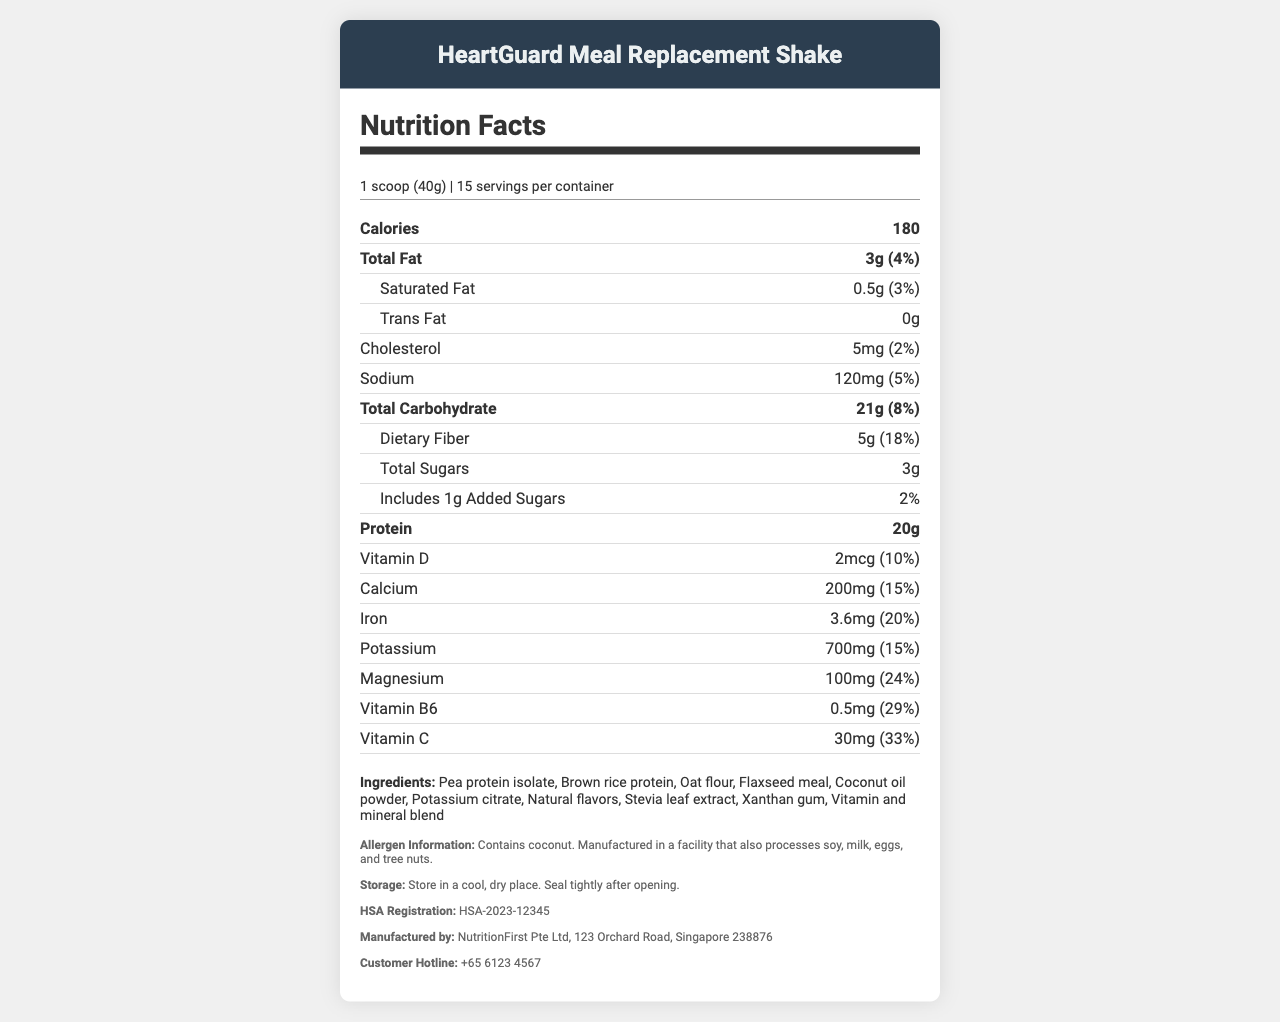what is the product name? The product name is clearly stated at the top of the document.
Answer: HeartGuard Meal Replacement Shake how many servings are there per container? The document lists "servings per container" as 15.
Answer: 15 servings how much potassium is there per serving? The document under the potassium section lists the amount as 700mg.
Answer: 700mg what is the daily value percentage of dietary fiber? The document specifies the daily value percentage of dietary fiber as 18%.
Answer: 18% what is the total carbohydrate content per serving? The total carbohydrate content per serving is listed as 21g.
Answer: 21g how many calories are there per serving? A. 150 B. 180 C. 200 The document lists the calorie content per serving as 180.
Answer: B which of the following is not an ingredient in the HeartGuard Meal Replacement Shake? I. Pea protein isolate II. Brown rice protein III. Rye flour The ingredients list includes pea protein isolate and brown rice protein but does not mention rye flour.
Answer: III does the product contain any allergens? The allergen information on the document states that the product contains coconut.
Answer: Yes is the product registered with the Singapore Health Sciences Authority (HSA)? The document includes an HSA registration number: HSA-2023-12345.
Answer: Yes summarize the main point of this document. The document is primarily a nutrition facts label aimed at informing the consumer about the important nutritional and ingredient details of the meal replacement shake specifically formulated for individuals with high blood pressure.
Answer: The document provides detailed nutritional information about the HeartGuard Meal Replacement Shake, including its serving size, calories, macronutrient content, vitamins, and minerals. It also lists the ingredients, allergen information, storage instructions, HSA registration, manufacturer details, and customer hotline. what is the proportion of added sugars in this product? The document lists the amount of added sugars but does not provide the proportion in relation to the total sugars or overall carbohydrate content.
Answer: Not enough information 